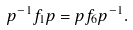Convert formula to latex. <formula><loc_0><loc_0><loc_500><loc_500>p ^ { - 1 } f _ { 1 } p = p f _ { 6 } p ^ { - 1 } .</formula> 